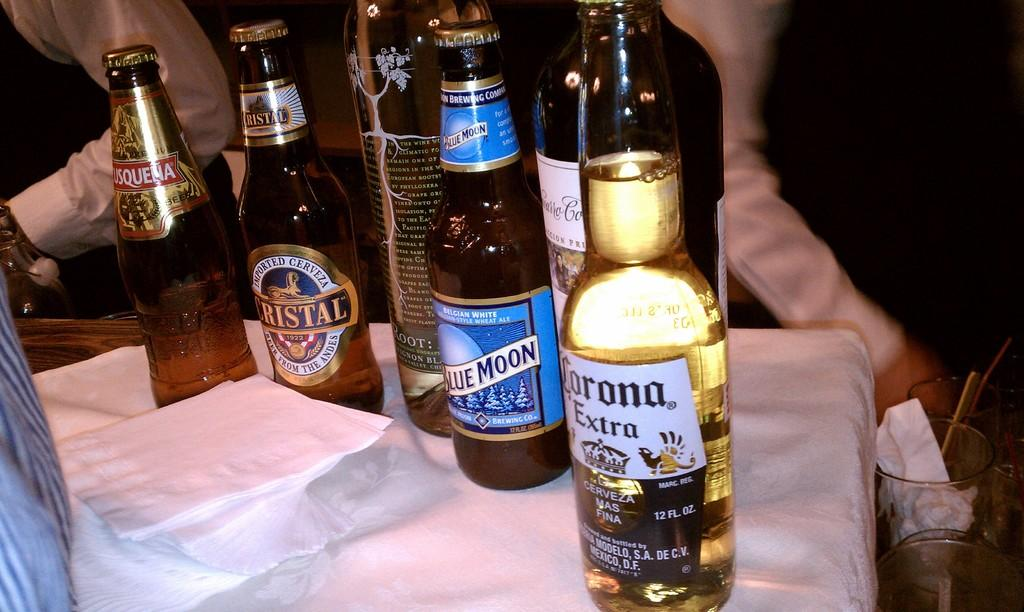<image>
Create a compact narrative representing the image presented. Several bottles including Blue Moon and Corona are sitting on a table. 